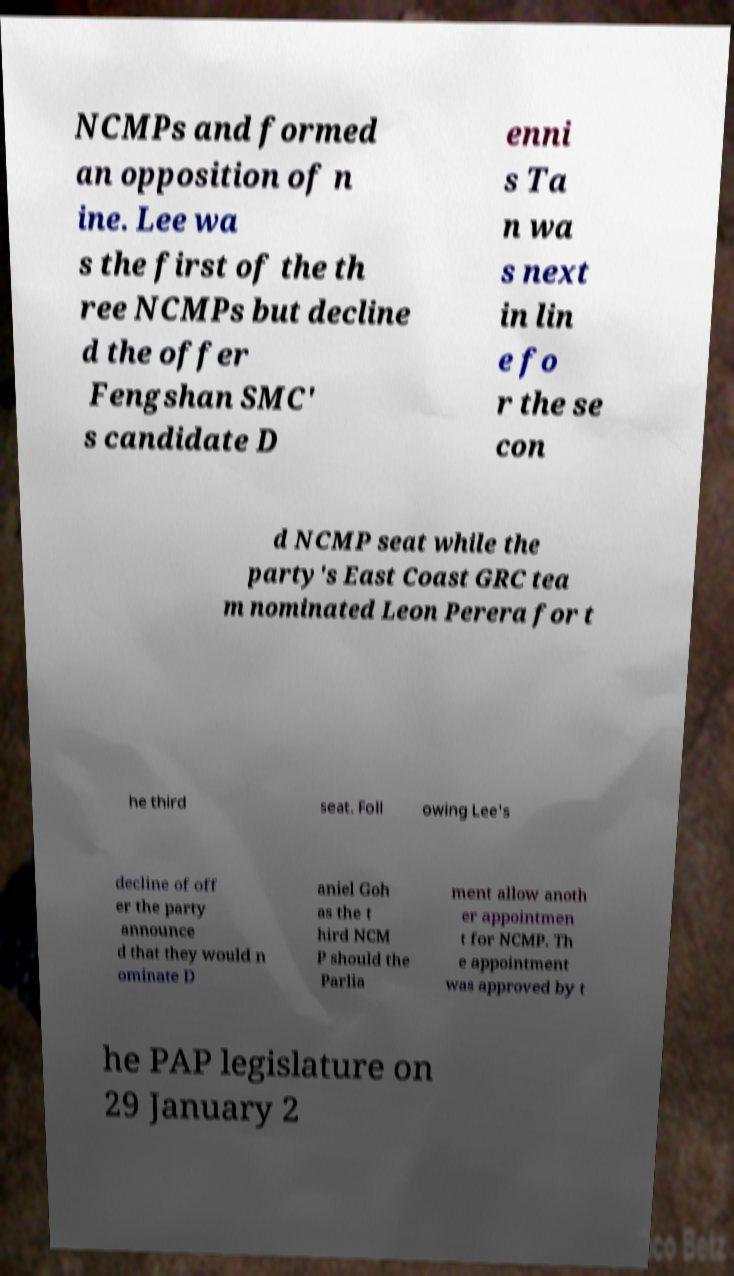For documentation purposes, I need the text within this image transcribed. Could you provide that? NCMPs and formed an opposition of n ine. Lee wa s the first of the th ree NCMPs but decline d the offer Fengshan SMC' s candidate D enni s Ta n wa s next in lin e fo r the se con d NCMP seat while the party's East Coast GRC tea m nominated Leon Perera for t he third seat. Foll owing Lee's decline of off er the party announce d that they would n ominate D aniel Goh as the t hird NCM P should the Parlia ment allow anoth er appointmen t for NCMP. Th e appointment was approved by t he PAP legislature on 29 January 2 